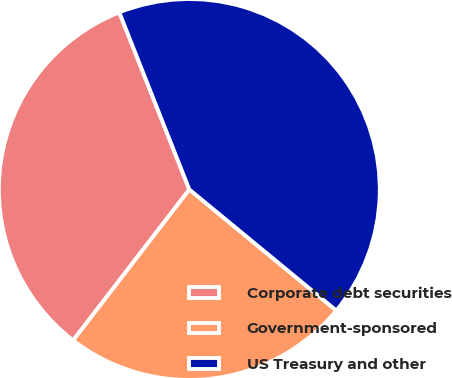Convert chart. <chart><loc_0><loc_0><loc_500><loc_500><pie_chart><fcel>Corporate debt securities<fcel>Government-sponsored<fcel>US Treasury and other<nl><fcel>33.57%<fcel>24.48%<fcel>41.96%<nl></chart> 